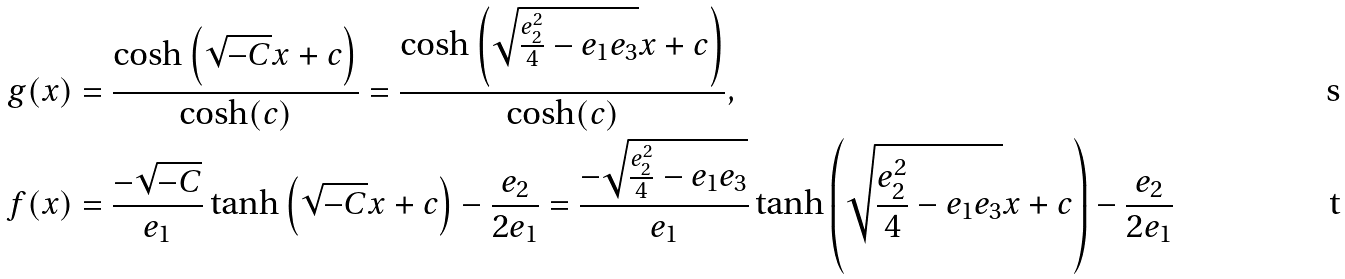<formula> <loc_0><loc_0><loc_500><loc_500>g ( x ) & = \frac { \cosh \left ( \sqrt { - C } x + c \right ) } { \cosh ( c ) } = \frac { \cosh \left ( \sqrt { \frac { e _ { 2 } ^ { 2 } } { 4 } - e _ { 1 } e _ { 3 } } x + c \right ) } { \cosh ( c ) } , \\ f ( x ) & = \frac { - \sqrt { - C } } { e _ { 1 } } \tanh \left ( \sqrt { - C } x + c \right ) - \frac { e _ { 2 } } { 2 e _ { 1 } } = \frac { - \sqrt { \frac { e _ { 2 } ^ { 2 } } { 4 } - e _ { 1 } e _ { 3 } } } { e _ { 1 } } \tanh \left ( \sqrt { \frac { e _ { 2 } ^ { 2 } } { 4 } - e _ { 1 } e _ { 3 } } x + c \right ) - \frac { e _ { 2 } } { 2 e _ { 1 } }</formula> 